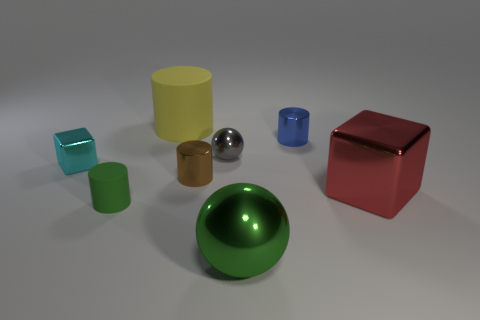The yellow matte cylinder is what size? The yellow matte cylinder appears to be of medium size compared to the other objects in the image, suggesting a balanced and moderate scale. 